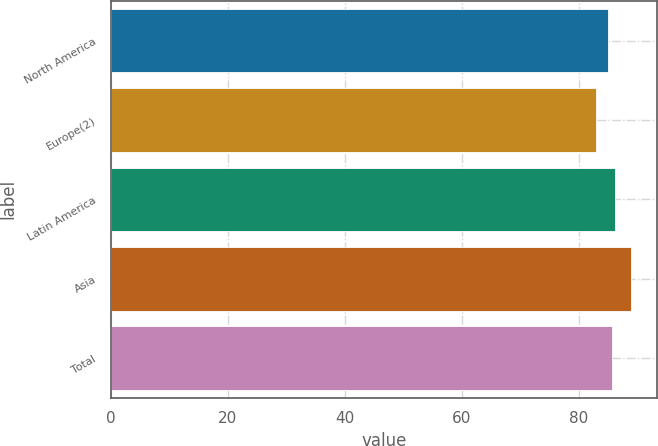Convert chart to OTSL. <chart><loc_0><loc_0><loc_500><loc_500><bar_chart><fcel>North America<fcel>Europe(2)<fcel>Latin America<fcel>Asia<fcel>Total<nl><fcel>85<fcel>83<fcel>86.2<fcel>89<fcel>85.6<nl></chart> 